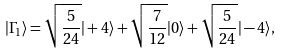Convert formula to latex. <formula><loc_0><loc_0><loc_500><loc_500>| \Gamma _ { 1 } \rangle = \sqrt { \frac { 5 } { 2 4 } } | + 4 \rangle + \sqrt { \frac { 7 } { 1 2 } } | 0 \rangle + \sqrt { \frac { 5 } { 2 4 } } | - 4 \rangle ,</formula> 